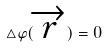Convert formula to latex. <formula><loc_0><loc_0><loc_500><loc_500>\triangle \varphi ( \overrightarrow { r } ) = 0</formula> 